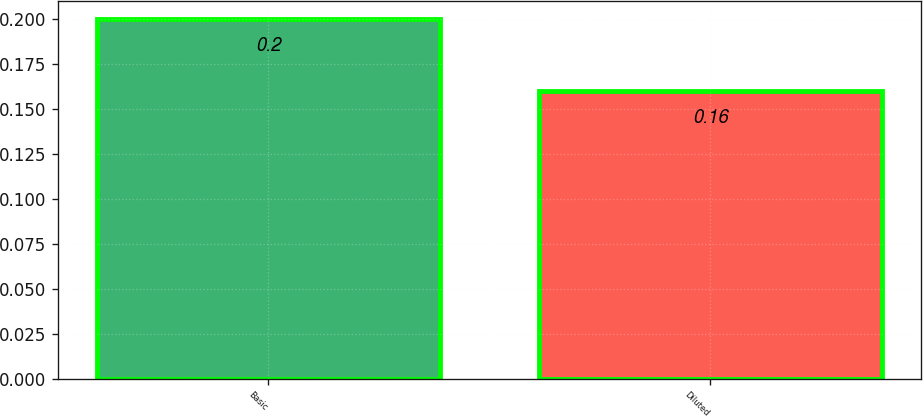Convert chart to OTSL. <chart><loc_0><loc_0><loc_500><loc_500><bar_chart><fcel>Basic<fcel>Diluted<nl><fcel>0.2<fcel>0.16<nl></chart> 